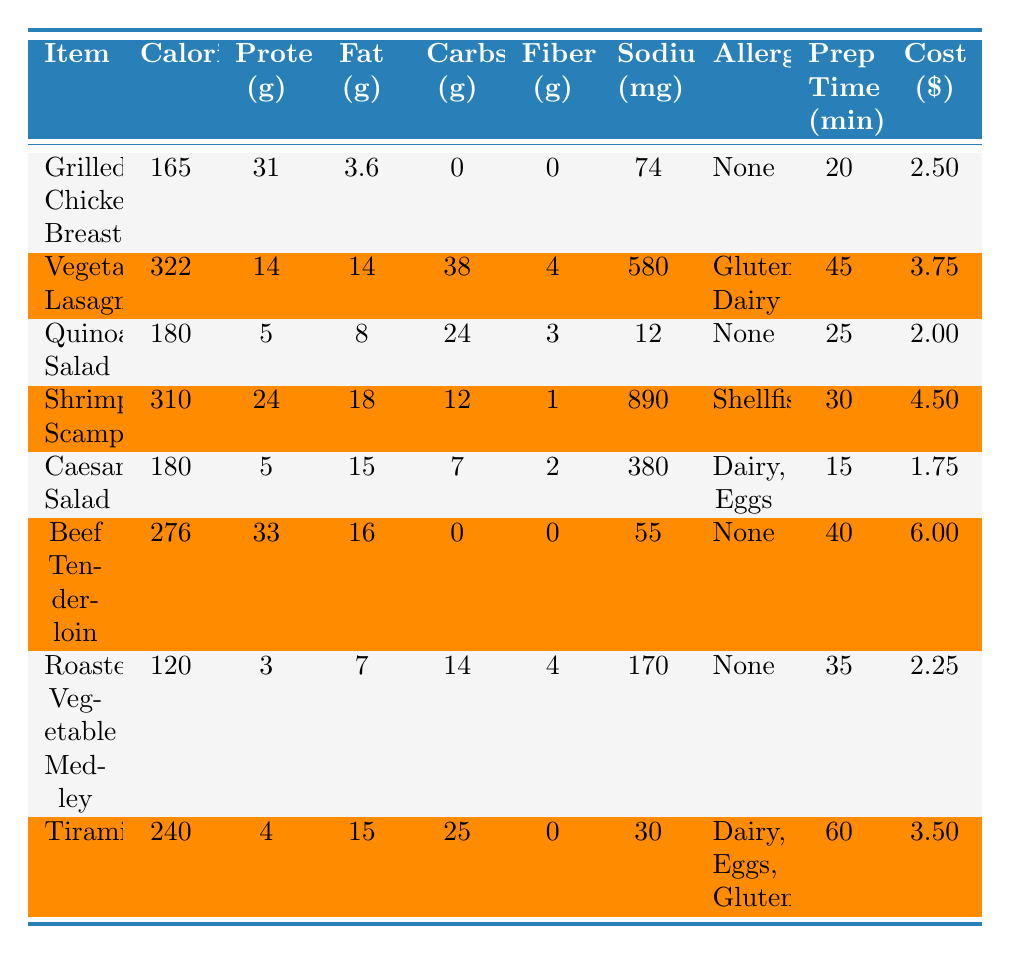What is the calorie content of the Shrimp Scampi? The calorie content for Shrimp Scampi can be found directly in the table under the "Calories" column. It shows 310 calories.
Answer: 310 How much protein does the Vegetable Lasagna contain? The amount of protein in the Vegetable Lasagna is listed in the "Protein (g)" column, which shows 14 grams.
Answer: 14 Which item has the highest sodium content? By comparing the "Sodium (mg)" column, Shrimp Scampi has the highest sodium content at 890 mg.
Answer: 890 What is the total prep time for Grilled Chicken Breast and Quinoa Salad combined? The prep time for Grilled Chicken Breast is 20 minutes and for Quinoa Salad is 25 minutes. Adding these gives 20 + 25 = 45 minutes total prep time.
Answer: 45 Is the Beef Tenderloin free from allergens? Looking at the "Allergens" column for Beef Tenderloin, it states "None," indicating it is allergen-free.
Answer: Yes What is the average calorie content of the salads (Caesar Salad and Quinoa Salad)? The calorie content of Caesar Salad is 180 calories and Quinoa Salad is 180 calories. The average is (180 + 180) / 2 = 180 calories.
Answer: 180 How many items have gluten as an allergen? By scanning the "Allergens" column, Vegetable Lasagna and Tiramisu are the only items listed with gluten as an allergen, totaling 2 items.
Answer: 2 Which item has the lowest fat content, and what is its value? Scanning the "Fat (g)" column, Roasted Vegetable Medley has the lowest fat content at 7 grams.
Answer: 7 What is the total cost per serving for the Vegetable Lasagna and Tiramisu? The cost per serving for Vegetable Lasagna is $3.75 and for Tiramisu is $3.50. Adding these gives 3.75 + 3.50 = $7.25 total.
Answer: 7.25 Which item has the highest protein content, and what is the amount? Looking at the "Protein (g)" column, Beef Tenderloin has the highest protein content at 33 grams.
Answer: 33 